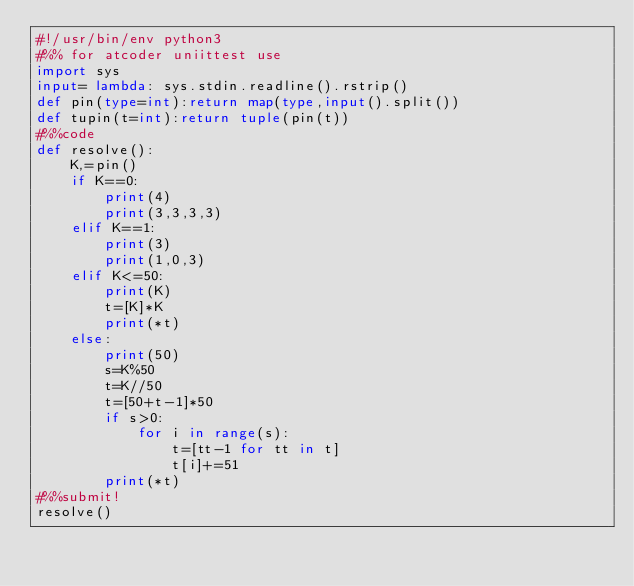Convert code to text. <code><loc_0><loc_0><loc_500><loc_500><_Python_>#!/usr/bin/env python3
#%% for atcoder uniittest use
import sys
input= lambda: sys.stdin.readline().rstrip()
def pin(type=int):return map(type,input().split())
def tupin(t=int):return tuple(pin(t))
#%%code
def resolve():
    K,=pin()
    if K==0:
        print(4)
        print(3,3,3,3)
    elif K==1:
        print(3)
        print(1,0,3)
    elif K<=50:
        print(K)
        t=[K]*K
        print(*t)
    else:
        print(50)
        s=K%50
        t=K//50
        t=[50+t-1]*50
        if s>0:
            for i in range(s):
                t=[tt-1 for tt in t]
                t[i]+=51
        print(*t)
#%%submit!
resolve()</code> 